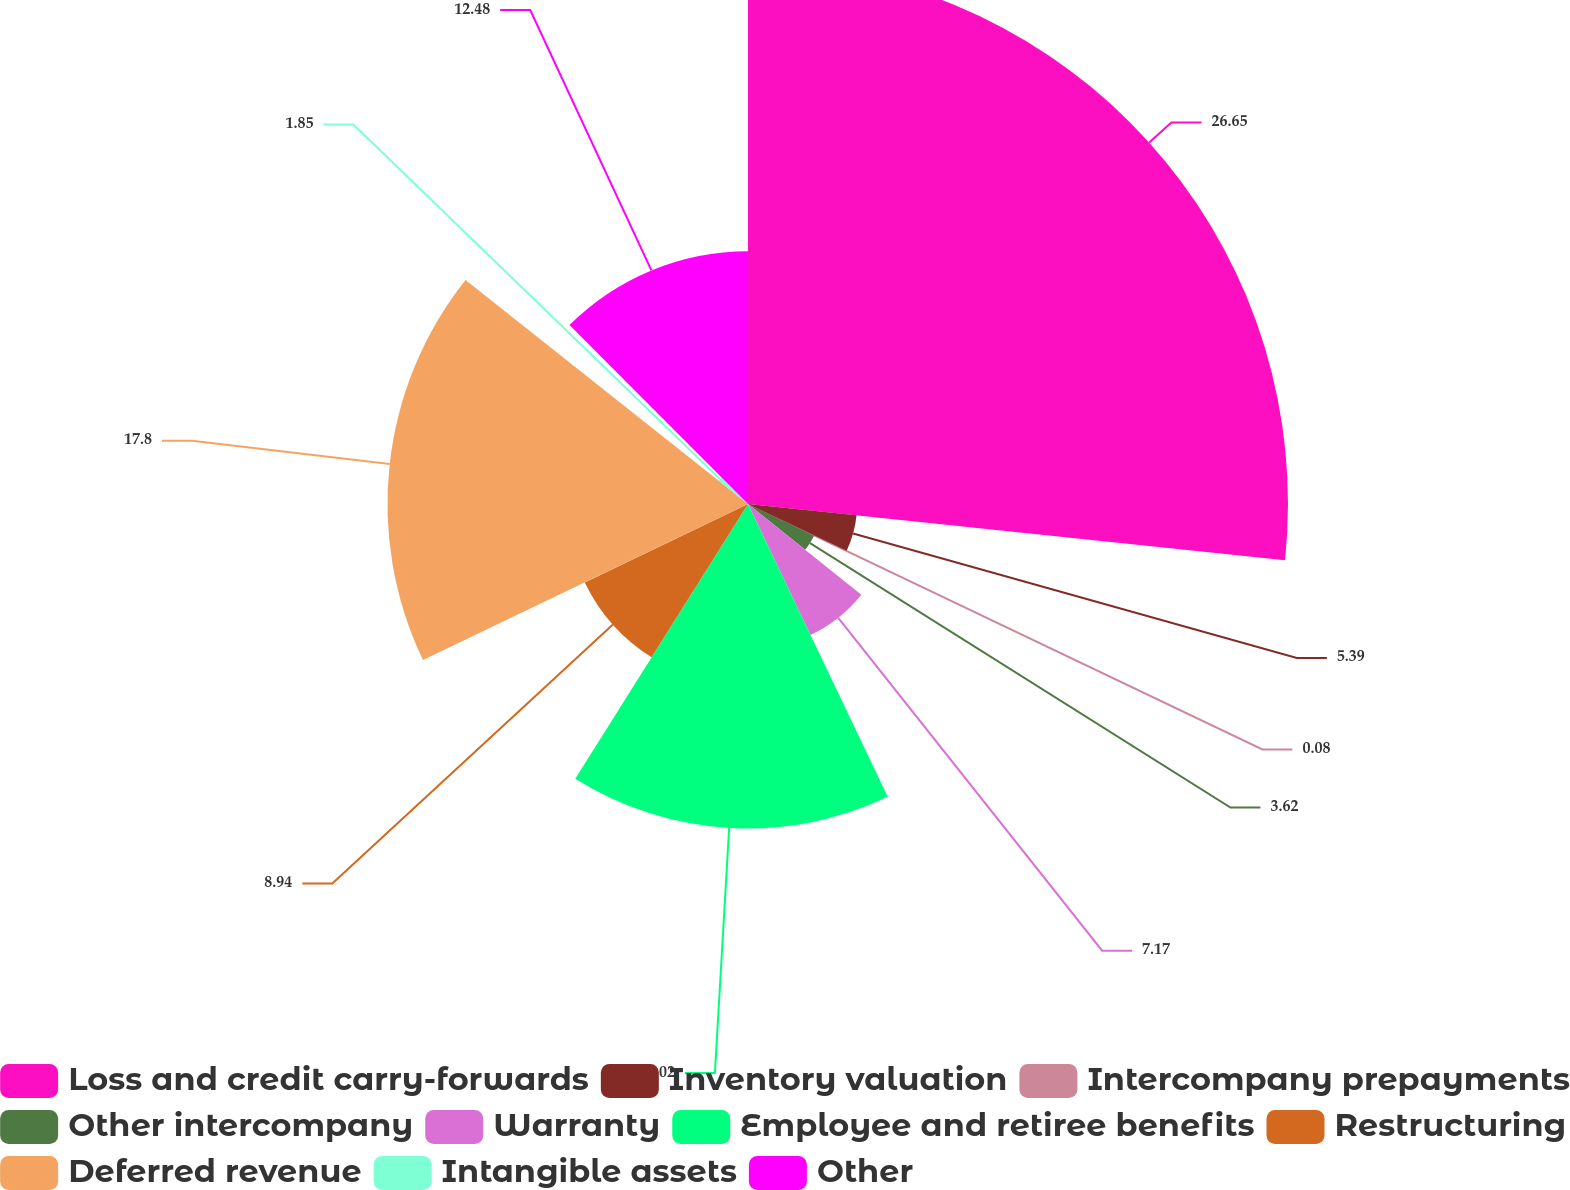Convert chart to OTSL. <chart><loc_0><loc_0><loc_500><loc_500><pie_chart><fcel>Loss and credit carry-forwards<fcel>Inventory valuation<fcel>Intercompany prepayments<fcel>Other intercompany<fcel>Warranty<fcel>Employee and retiree benefits<fcel>Restructuring<fcel>Deferred revenue<fcel>Intangible assets<fcel>Other<nl><fcel>26.66%<fcel>5.39%<fcel>0.08%<fcel>3.62%<fcel>7.17%<fcel>16.02%<fcel>8.94%<fcel>17.8%<fcel>1.85%<fcel>12.48%<nl></chart> 